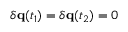Convert formula to latex. <formula><loc_0><loc_0><loc_500><loc_500>\delta q ( t _ { 1 } ) = \delta q ( t _ { 2 } ) = 0</formula> 